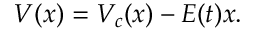Convert formula to latex. <formula><loc_0><loc_0><loc_500><loc_500>V ( x ) = V _ { c } ( x ) - E ( t ) x .</formula> 